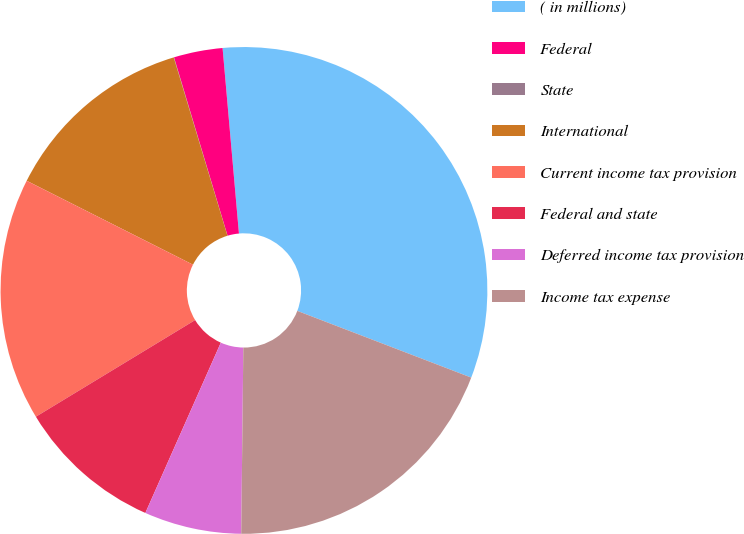Convert chart to OTSL. <chart><loc_0><loc_0><loc_500><loc_500><pie_chart><fcel>( in millions)<fcel>Federal<fcel>State<fcel>International<fcel>Current income tax provision<fcel>Federal and state<fcel>Deferred income tax provision<fcel>Income tax expense<nl><fcel>32.23%<fcel>3.24%<fcel>0.02%<fcel>12.9%<fcel>16.12%<fcel>9.68%<fcel>6.46%<fcel>19.35%<nl></chart> 